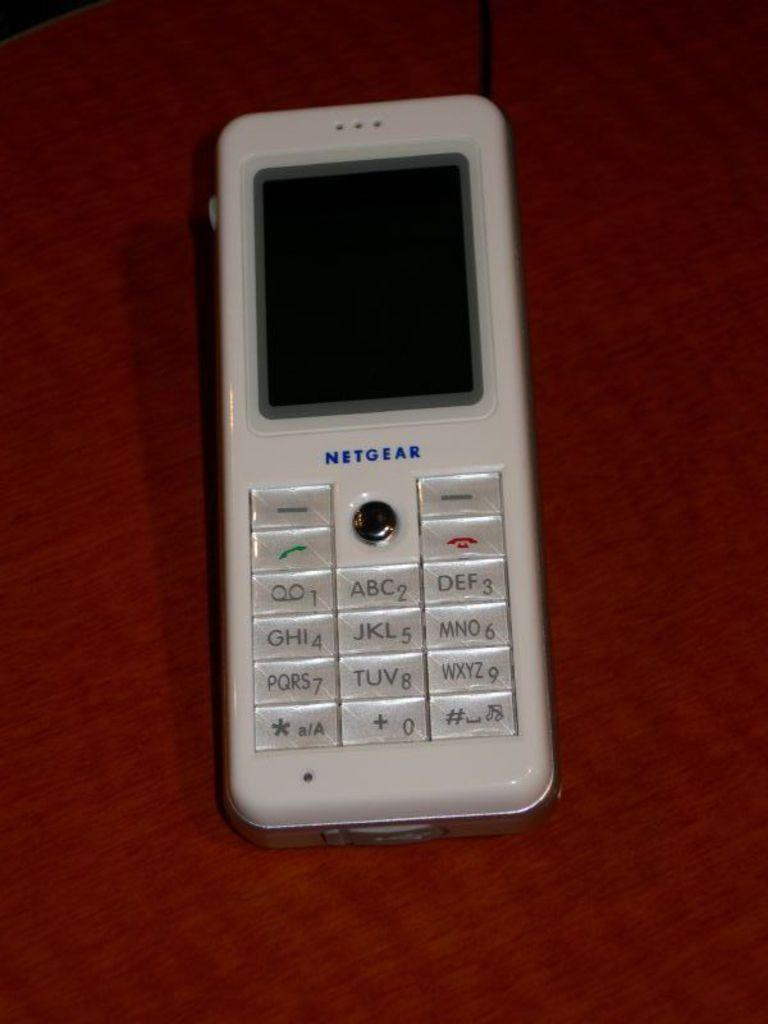<image>
Create a compact narrative representing the image presented. A white Netgear telephone is sitting on a red surface. 